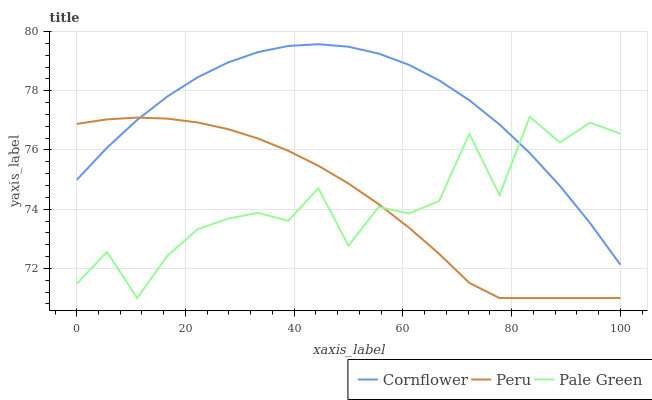Does Pale Green have the minimum area under the curve?
Answer yes or no. Yes. Does Cornflower have the maximum area under the curve?
Answer yes or no. Yes. Does Peru have the minimum area under the curve?
Answer yes or no. No. Does Peru have the maximum area under the curve?
Answer yes or no. No. Is Peru the smoothest?
Answer yes or no. Yes. Is Pale Green the roughest?
Answer yes or no. Yes. Is Pale Green the smoothest?
Answer yes or no. No. Is Peru the roughest?
Answer yes or no. No. Does Pale Green have the lowest value?
Answer yes or no. Yes. Does Cornflower have the highest value?
Answer yes or no. Yes. Does Pale Green have the highest value?
Answer yes or no. No. Does Pale Green intersect Cornflower?
Answer yes or no. Yes. Is Pale Green less than Cornflower?
Answer yes or no. No. Is Pale Green greater than Cornflower?
Answer yes or no. No. 